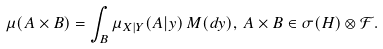<formula> <loc_0><loc_0><loc_500><loc_500>\mu ( A \times B ) = \int _ { B } \mu _ { X | Y } ( A | y ) \, M ( d y ) , \, A \times B \in \sigma ( H ) \otimes \mathcal { F } .</formula> 